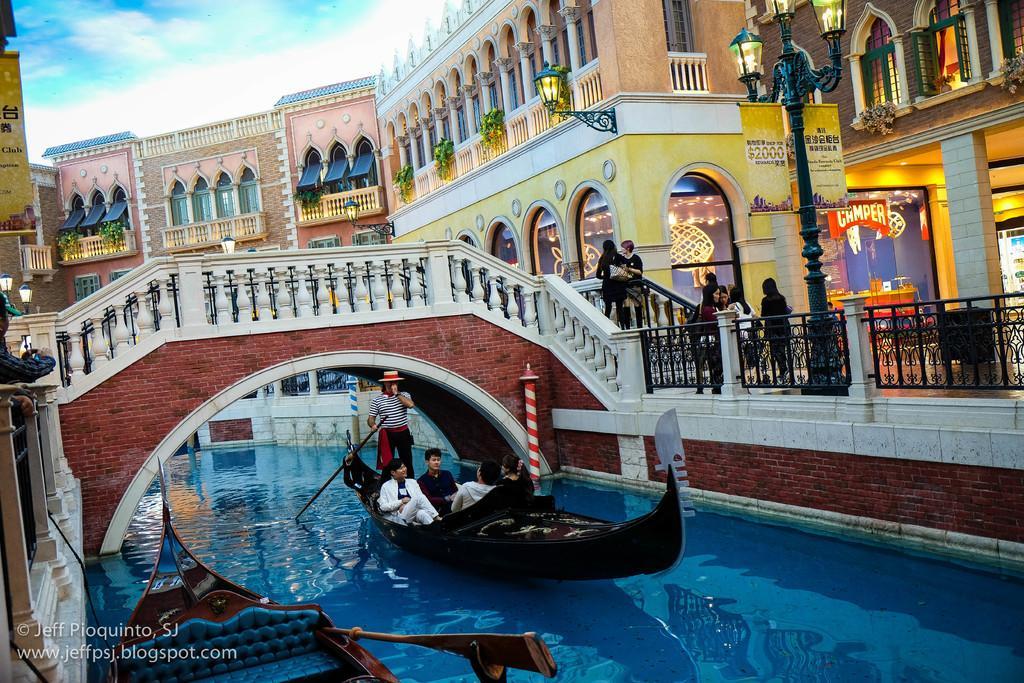How would you summarize this image in a sentence or two? There is a boat on the left and there is another boat on the right, 5 people sailing on it. The water seems to be too clear. There is a bridge over here and few people getting onto it and we see a man over here capturing on his phone and there are few buildings over here, painted beautifully and it is a clear sky. 